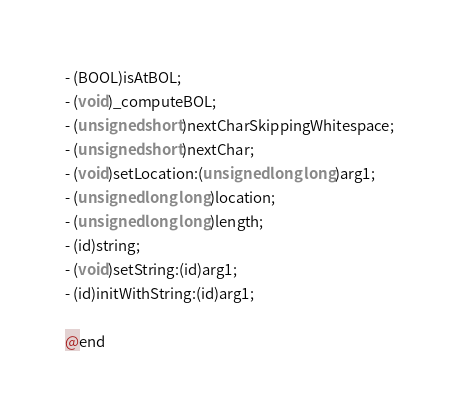Convert code to text. <code><loc_0><loc_0><loc_500><loc_500><_C_>- (BOOL)isAtBOL;
- (void)_computeBOL;
- (unsigned short)nextCharSkippingWhitespace;
- (unsigned short)nextChar;
- (void)setLocation:(unsigned long long)arg1;
- (unsigned long long)location;
- (unsigned long long)length;
- (id)string;
- (void)setString:(id)arg1;
- (id)initWithString:(id)arg1;

@end

</code> 